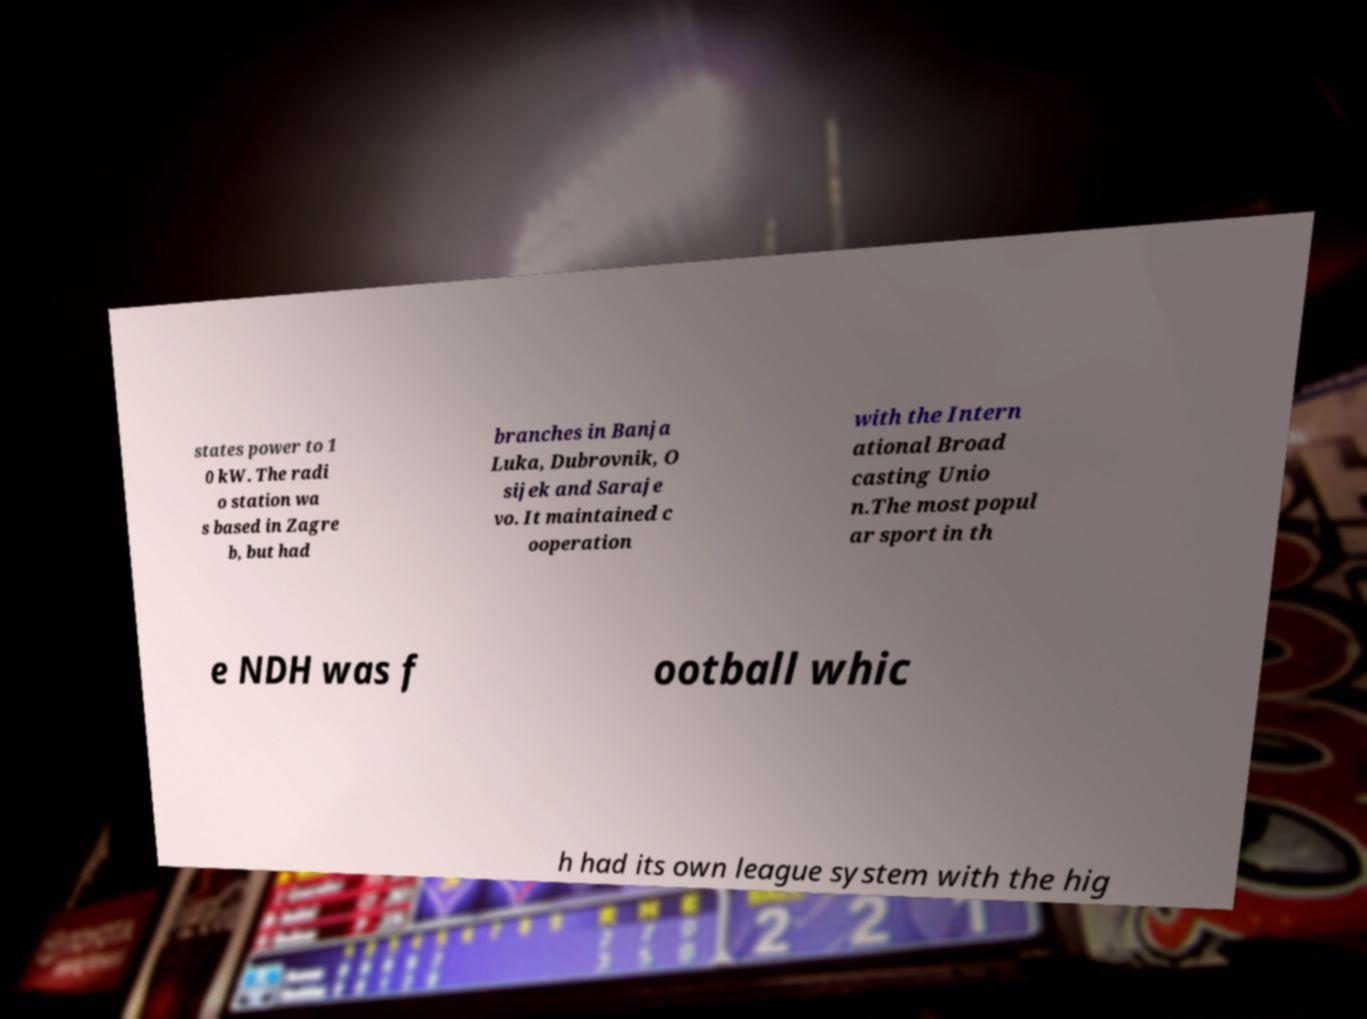For documentation purposes, I need the text within this image transcribed. Could you provide that? states power to 1 0 kW. The radi o station wa s based in Zagre b, but had branches in Banja Luka, Dubrovnik, O sijek and Saraje vo. It maintained c ooperation with the Intern ational Broad casting Unio n.The most popul ar sport in th e NDH was f ootball whic h had its own league system with the hig 